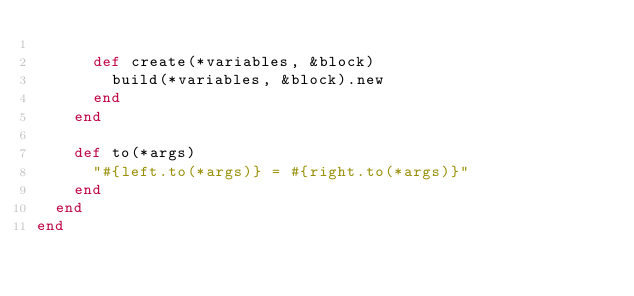<code> <loc_0><loc_0><loc_500><loc_500><_Ruby_>
      def create(*variables, &block)
        build(*variables, &block).new
      end
    end

    def to(*args)
      "#{left.to(*args)} = #{right.to(*args)}"
    end
  end
end
</code> 